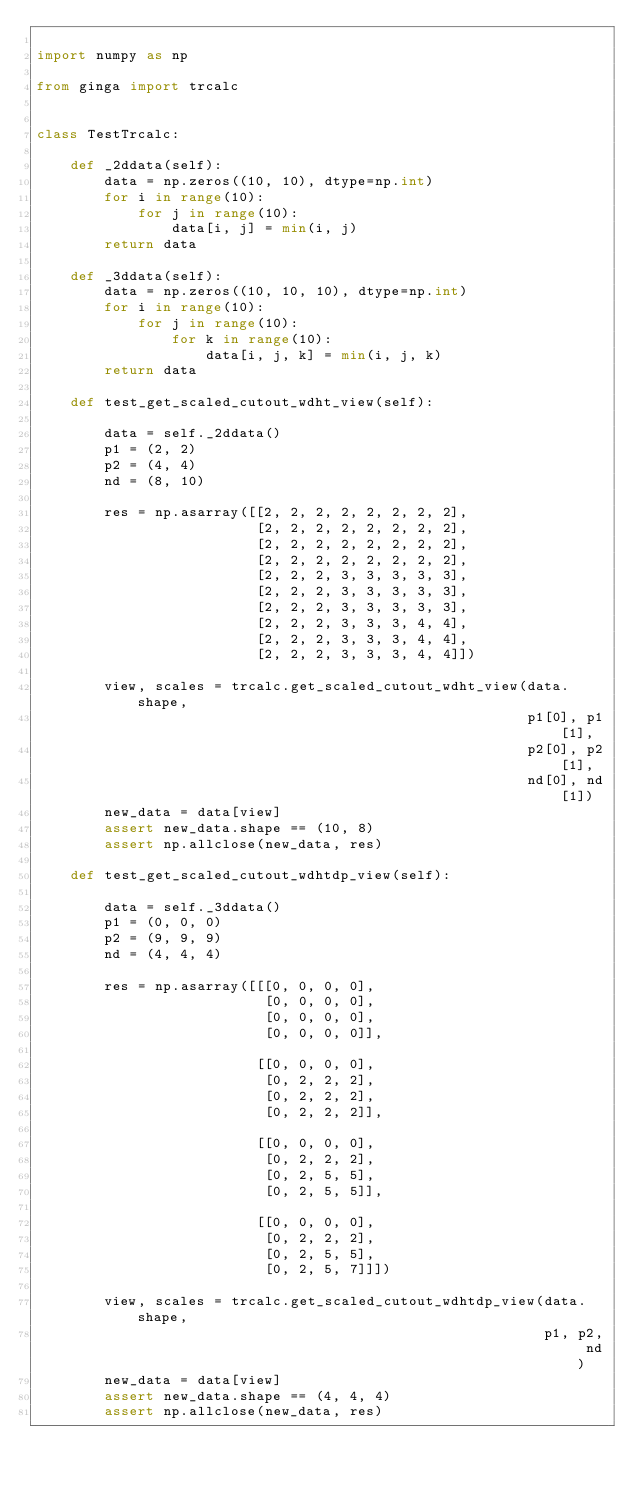Convert code to text. <code><loc_0><loc_0><loc_500><loc_500><_Python_>
import numpy as np

from ginga import trcalc


class TestTrcalc:

    def _2ddata(self):
        data = np.zeros((10, 10), dtype=np.int)
        for i in range(10):
            for j in range(10):
                data[i, j] = min(i, j)
        return data

    def _3ddata(self):
        data = np.zeros((10, 10, 10), dtype=np.int)
        for i in range(10):
            for j in range(10):
                for k in range(10):
                    data[i, j, k] = min(i, j, k)
        return data

    def test_get_scaled_cutout_wdht_view(self):

        data = self._2ddata()
        p1 = (2, 2)
        p2 = (4, 4)
        nd = (8, 10)

        res = np.asarray([[2, 2, 2, 2, 2, 2, 2, 2],
                          [2, 2, 2, 2, 2, 2, 2, 2],
                          [2, 2, 2, 2, 2, 2, 2, 2],
                          [2, 2, 2, 2, 2, 2, 2, 2],
                          [2, 2, 2, 3, 3, 3, 3, 3],
                          [2, 2, 2, 3, 3, 3, 3, 3],
                          [2, 2, 2, 3, 3, 3, 3, 3],
                          [2, 2, 2, 3, 3, 3, 4, 4],
                          [2, 2, 2, 3, 3, 3, 4, 4],
                          [2, 2, 2, 3, 3, 3, 4, 4]])

        view, scales = trcalc.get_scaled_cutout_wdht_view(data.shape,
                                                          p1[0], p1[1],
                                                          p2[0], p2[1],
                                                          nd[0], nd[1])
        new_data = data[view]
        assert new_data.shape == (10, 8)
        assert np.allclose(new_data, res)

    def test_get_scaled_cutout_wdhtdp_view(self):

        data = self._3ddata()
        p1 = (0, 0, 0)
        p2 = (9, 9, 9)
        nd = (4, 4, 4)

        res = np.asarray([[[0, 0, 0, 0],
                           [0, 0, 0, 0],
                           [0, 0, 0, 0],
                           [0, 0, 0, 0]],

                          [[0, 0, 0, 0],
                           [0, 2, 2, 2],
                           [0, 2, 2, 2],
                           [0, 2, 2, 2]],

                          [[0, 0, 0, 0],
                           [0, 2, 2, 2],
                           [0, 2, 5, 5],
                           [0, 2, 5, 5]],

                          [[0, 0, 0, 0],
                           [0, 2, 2, 2],
                           [0, 2, 5, 5],
                           [0, 2, 5, 7]]])

        view, scales = trcalc.get_scaled_cutout_wdhtdp_view(data.shape,
                                                            p1, p2, nd)
        new_data = data[view]
        assert new_data.shape == (4, 4, 4)
        assert np.allclose(new_data, res)
</code> 